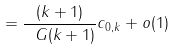<formula> <loc_0><loc_0><loc_500><loc_500>= \frac { ( k + 1 ) } { \ G ( k + 1 ) } c _ { 0 , k } + o ( 1 )</formula> 